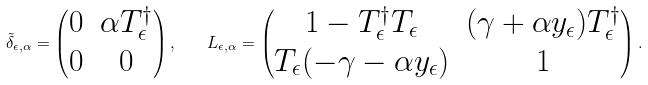Convert formula to latex. <formula><loc_0><loc_0><loc_500><loc_500>\tilde { \delta } _ { \epsilon , \alpha } = \begin{pmatrix} 0 & \alpha T ^ { \dagger } _ { \epsilon } \\ 0 & 0 \end{pmatrix} , \quad L _ { \epsilon , \alpha } = \begin{pmatrix} 1 - T _ { \epsilon } ^ { \dagger } T _ { \epsilon } & ( \gamma + \alpha y _ { \epsilon } ) T ^ { \dagger } _ { \epsilon } \\ T _ { \epsilon } ( - \gamma - \alpha y _ { \epsilon } ) & 1 \end{pmatrix} .</formula> 